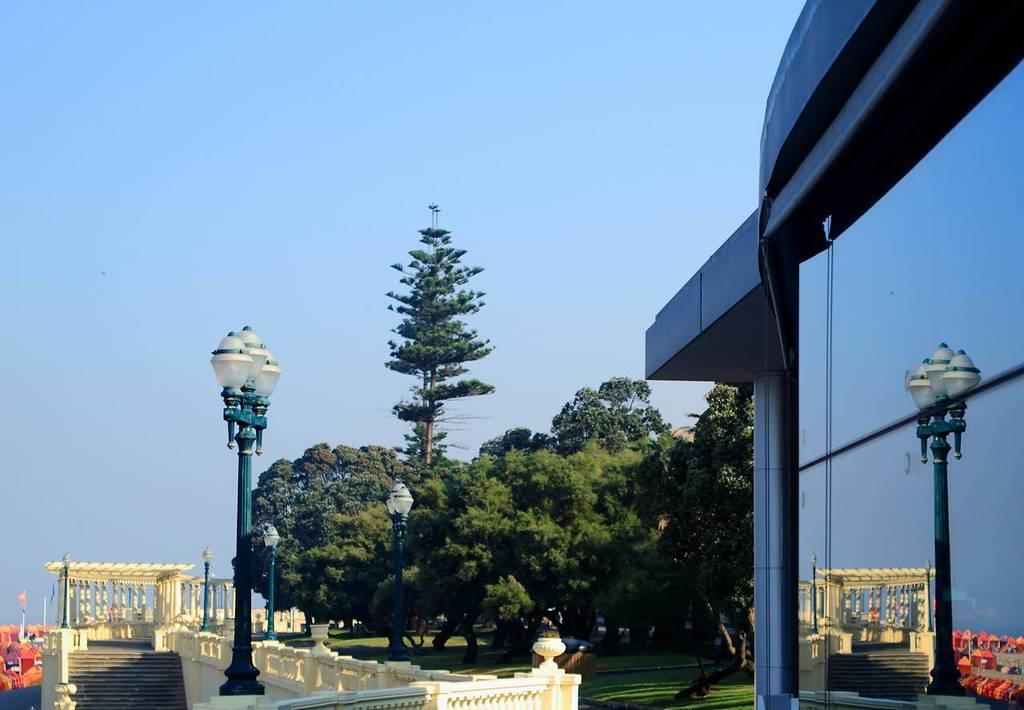What type of structure can be seen in the image? There is a building in the image. What is located on the left side of the image? There is a monument with pillars and stairs on the left side of the image. What are the street poles used for in the image? The street poles are present on the monument, likely for lighting or signage purposes. What type of vegetation is visible in the image? There is a group of trees and grass visible in the image. What part of the natural environment can be seen in the image? The sky is visible in the image. What type of comfort can be found in the image? The image does not depict any objects or elements related to comfort. Is there a hammer visible in the image? No, there is no hammer present in the image. 